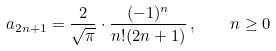Convert formula to latex. <formula><loc_0><loc_0><loc_500><loc_500>a _ { 2 n + 1 } = \frac { 2 } { \sqrt { \pi } } \cdot \frac { ( - 1 ) ^ { n } } { n ! ( 2 n + 1 ) } \, , \quad n \geq 0</formula> 